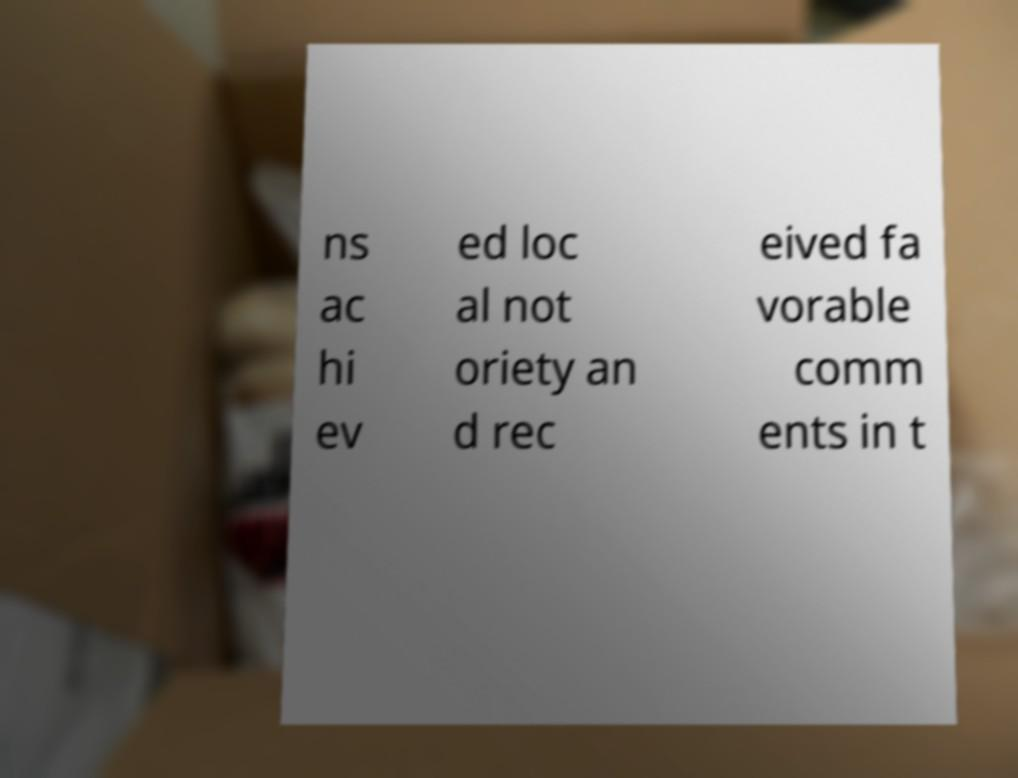I need the written content from this picture converted into text. Can you do that? ns ac hi ev ed loc al not oriety an d rec eived fa vorable comm ents in t 